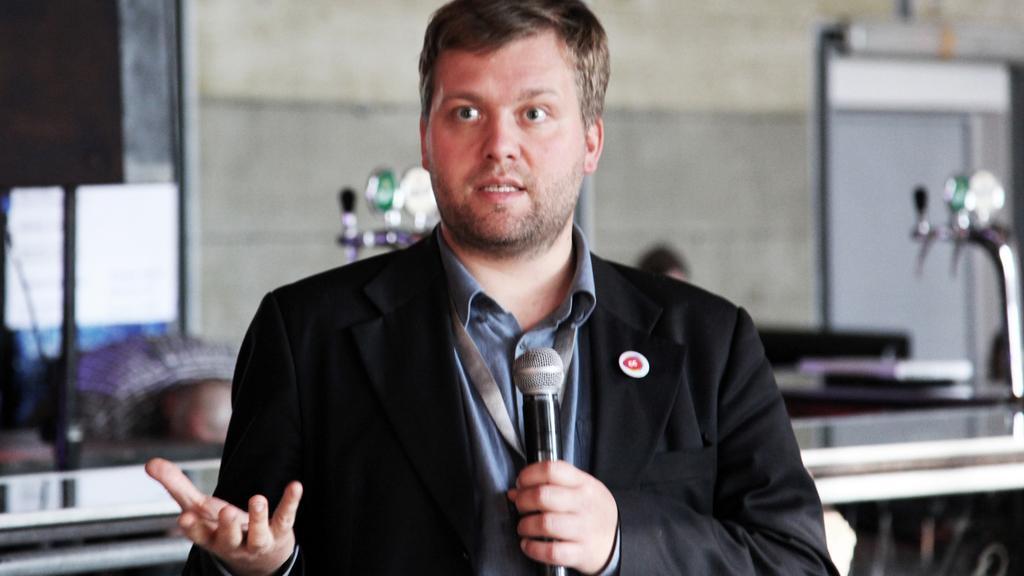Could you give a brief overview of what you see in this image? Front this man wore black suit and holding a mic. Background is blurry. This man is speaking in-front of mic. 